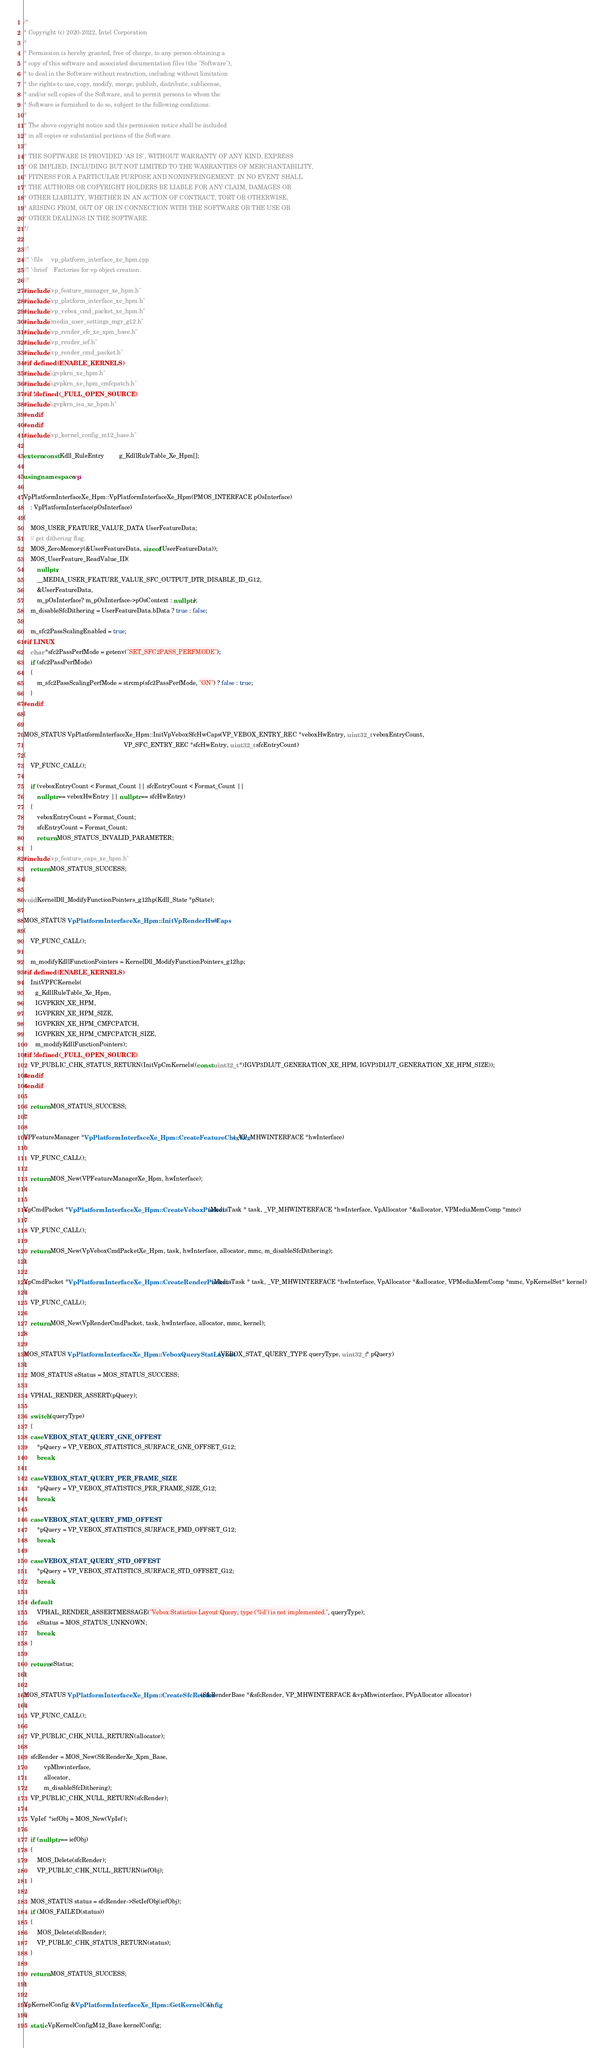<code> <loc_0><loc_0><loc_500><loc_500><_C++_>/*
* Copyright (c) 2020-2022, Intel Corporation
*
* Permission is hereby granted, free of charge, to any person obtaining a
* copy of this software and associated documentation files (the "Software"),
* to deal in the Software without restriction, including without limitation
* the rights to use, copy, modify, merge, publish, distribute, sublicense,
* and/or sell copies of the Software, and to permit persons to whom the
* Software is furnished to do so, subject to the following conditions:
*
* The above copyright notice and this permission notice shall be included
* in all copies or substantial portions of the Software.
*
* THE SOFTWARE IS PROVIDED "AS IS", WITHOUT WARRANTY OF ANY KIND, EXPRESS
* OR IMPLIED, INCLUDING BUT NOT LIMITED TO THE WARRANTIES OF MERCHANTABILITY,
* FITNESS FOR A PARTICULAR PURPOSE AND NONINFRINGEMENT. IN NO EVENT SHALL
* THE AUTHORS OR COPYRIGHT HOLDERS BE LIABLE FOR ANY CLAIM, DAMAGES OR
* OTHER LIABILITY, WHETHER IN AN ACTION OF CONTRACT, TORT OR OTHERWISE,
* ARISING FROM, OUT OF OR IN CONNECTION WITH THE SOFTWARE OR THE USE OR
* OTHER DEALINGS IN THE SOFTWARE.
*/

//!
//! \file     vp_platform_interface_xe_hpm.cpp
//! \brief    Factories for vp object creation.
//!
#include "vp_feature_manager_xe_hpm.h"
#include "vp_platform_interface_xe_hpm.h"
#include "vp_vebox_cmd_packet_xe_hpm.h"
#include "media_user_settings_mgr_g12.h"
#include "vp_render_sfc_xe_xpm_base.h"
#include "vp_render_ief.h"
#include "vp_render_cmd_packet.h"
#if defined(ENABLE_KERNELS)
#include "igvpkrn_xe_hpm.h"
#include "igvpkrn_xe_hpm_cmfcpatch.h"
#if !defined(_FULL_OPEN_SOURCE)
#include "igvpkrn_isa_xe_hpm.h"
#endif
#endif
#include "vp_kernel_config_m12_base.h"

extern const Kdll_RuleEntry         g_KdllRuleTable_Xe_Hpm[];

using namespace vp;

VpPlatformInterfaceXe_Hpm::VpPlatformInterfaceXe_Hpm(PMOS_INTERFACE pOsInterface)
    : VpPlatformInterface(pOsInterface)
{
    MOS_USER_FEATURE_VALUE_DATA UserFeatureData;
    // get dithering flag.
    MOS_ZeroMemory(&UserFeatureData, sizeof(UserFeatureData));
    MOS_UserFeature_ReadValue_ID(
        nullptr,
        __MEDIA_USER_FEATURE_VALUE_SFC_OUTPUT_DTR_DISABLE_ID_G12,
        &UserFeatureData,
        m_pOsInterface? m_pOsInterface->pOsContext : nullptr);
    m_disableSfcDithering = UserFeatureData.bData ? true : false;

    m_sfc2PassScalingEnabled = true;
#if LINUX
    char *sfc2PassPerfMode = getenv("SET_SFC2PASS_PERFMODE");
    if (sfc2PassPerfMode)
    {
        m_sfc2PassScalingPerfMode = strcmp(sfc2PassPerfMode, "ON") ? false : true;
    }
#endif
}

MOS_STATUS VpPlatformInterfaceXe_Hpm::InitVpVeboxSfcHwCaps(VP_VEBOX_ENTRY_REC *veboxHwEntry, uint32_t veboxEntryCount,
                                                            VP_SFC_ENTRY_REC *sfcHwEntry, uint32_t sfcEntryCount)
{
    VP_FUNC_CALL();

    if (veboxEntryCount < Format_Count || sfcEntryCount < Format_Count ||
        nullptr == veboxHwEntry || nullptr == sfcHwEntry)
    {
        veboxEntryCount = Format_Count;
        sfcEntryCount = Format_Count;
        return MOS_STATUS_INVALID_PARAMETER;
    }
#include "vp_feature_caps_xe_hpm.h"
    return MOS_STATUS_SUCCESS;
}

void KernelDll_ModifyFunctionPointers_g12hp(Kdll_State *pState);

MOS_STATUS VpPlatformInterfaceXe_Hpm::InitVpRenderHwCaps()
{
    VP_FUNC_CALL();

    m_modifyKdllFunctionPointers = KernelDll_ModifyFunctionPointers_g12hp;
#if defined(ENABLE_KERNELS)
    InitVPFCKernels(
       g_KdllRuleTable_Xe_Hpm,
       IGVPKRN_XE_HPM,
       IGVPKRN_XE_HPM_SIZE,
       IGVPKRN_XE_HPM_CMFCPATCH,
       IGVPKRN_XE_HPM_CMFCPATCH_SIZE,
       m_modifyKdllFunctionPointers);
#if !defined(_FULL_OPEN_SOURCE)
    VP_PUBLIC_CHK_STATUS_RETURN(InitVpCmKernels((const uint32_t *)IGVP3DLUT_GENERATION_XE_HPM, IGVP3DLUT_GENERATION_XE_HPM_SIZE));
#endif
#endif

    return MOS_STATUS_SUCCESS;
}

VPFeatureManager *VpPlatformInterfaceXe_Hpm::CreateFeatureChecker(_VP_MHWINTERFACE *hwInterface)
{
    VP_FUNC_CALL();

    return MOS_New(VPFeatureManagerXe_Hpm, hwInterface);
}

VpCmdPacket *VpPlatformInterfaceXe_Hpm::CreateVeboxPacket(MediaTask * task, _VP_MHWINTERFACE *hwInterface, VpAllocator *&allocator, VPMediaMemComp *mmc)
{
    VP_FUNC_CALL();

    return MOS_New(VpVeboxCmdPacketXe_Hpm, task, hwInterface, allocator, mmc, m_disableSfcDithering);
}

VpCmdPacket *VpPlatformInterfaceXe_Hpm::CreateRenderPacket(MediaTask * task, _VP_MHWINTERFACE *hwInterface, VpAllocator *&allocator, VPMediaMemComp *mmc, VpKernelSet* kernel)
{
    VP_FUNC_CALL();

    return MOS_New(VpRenderCmdPacket, task, hwInterface, allocator, mmc, kernel);
}

MOS_STATUS VpPlatformInterfaceXe_Hpm::VeboxQueryStatLayout(VEBOX_STAT_QUERY_TYPE queryType, uint32_t* pQuery)
{
    MOS_STATUS eStatus = MOS_STATUS_SUCCESS;

    VPHAL_RENDER_ASSERT(pQuery);

    switch (queryType)
    {
    case VEBOX_STAT_QUERY_GNE_OFFEST:
        *pQuery = VP_VEBOX_STATISTICS_SURFACE_GNE_OFFSET_G12;
        break;

    case VEBOX_STAT_QUERY_PER_FRAME_SIZE:
        *pQuery = VP_VEBOX_STATISTICS_PER_FRAME_SIZE_G12;
        break;

    case VEBOX_STAT_QUERY_FMD_OFFEST:
        *pQuery = VP_VEBOX_STATISTICS_SURFACE_FMD_OFFSET_G12;
        break;

    case VEBOX_STAT_QUERY_STD_OFFEST:
        *pQuery = VP_VEBOX_STATISTICS_SURFACE_STD_OFFSET_G12;
        break;

    default:
        VPHAL_RENDER_ASSERTMESSAGE("Vebox Statistics Layout Query, type ('%d') is not implemented.", queryType);
        eStatus = MOS_STATUS_UNKNOWN;
        break;
    }

    return eStatus;
}

MOS_STATUS VpPlatformInterfaceXe_Hpm::CreateSfcRender(SfcRenderBase *&sfcRender, VP_MHWINTERFACE &vpMhwinterface, PVpAllocator allocator)
{
    VP_FUNC_CALL();

    VP_PUBLIC_CHK_NULL_RETURN(allocator);

    sfcRender = MOS_New(SfcRenderXe_Xpm_Base,
            vpMhwinterface,
            allocator,
            m_disableSfcDithering);
    VP_PUBLIC_CHK_NULL_RETURN(sfcRender);

    VpIef *iefObj = MOS_New(VpIef);

    if (nullptr == iefObj)
    {
        MOS_Delete(sfcRender);
        VP_PUBLIC_CHK_NULL_RETURN(iefObj);
    }

    MOS_STATUS status = sfcRender->SetIefObj(iefObj);
    if (MOS_FAILED(status))
    {
        MOS_Delete(sfcRender);
        VP_PUBLIC_CHK_STATUS_RETURN(status);
    }

    return MOS_STATUS_SUCCESS;
}

VpKernelConfig &VpPlatformInterfaceXe_Hpm::GetKernelConfig()
{
    static VpKernelConfigM12_Base kernelConfig;</code> 